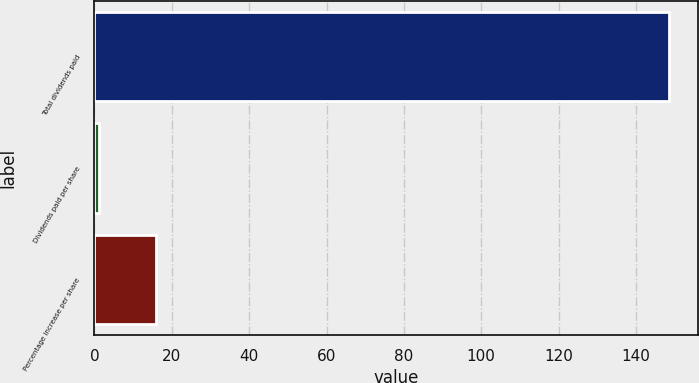Convert chart. <chart><loc_0><loc_0><loc_500><loc_500><bar_chart><fcel>Total dividends paid<fcel>Dividends paid per share<fcel>Percentage increase per share<nl><fcel>148.5<fcel>1.12<fcel>15.86<nl></chart> 